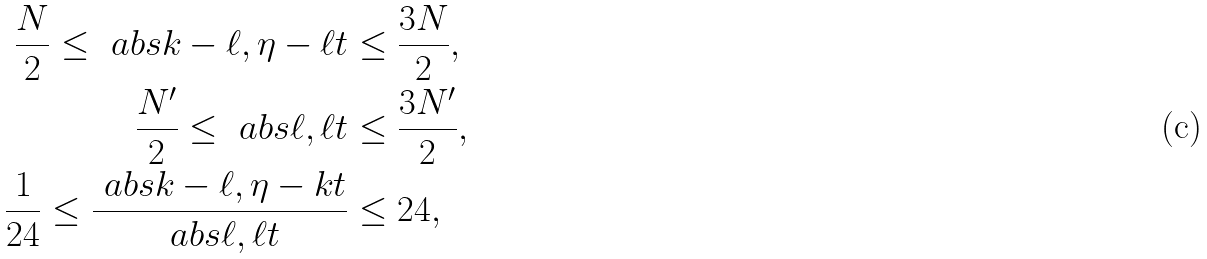<formula> <loc_0><loc_0><loc_500><loc_500>\frac { N } { 2 } \leq \ a b s { k - \ell , \eta - \ell t } & \leq \frac { 3 N } { 2 } , \\ \frac { N ^ { \prime } } { 2 } \leq \ a b s { \ell , \ell t } & \leq \frac { 3 N ^ { \prime } } { 2 } , \\ \frac { 1 } { 2 4 } \leq \frac { \ a b s { k - \ell , \eta - k t } } { \ a b s { \ell , \ell t } } & \leq 2 4 ,</formula> 